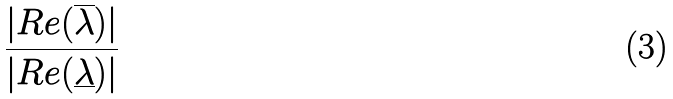Convert formula to latex. <formula><loc_0><loc_0><loc_500><loc_500>\frac { | R e ( \overline { \lambda } ) | } { | R e ( \underline { \lambda } ) | }</formula> 